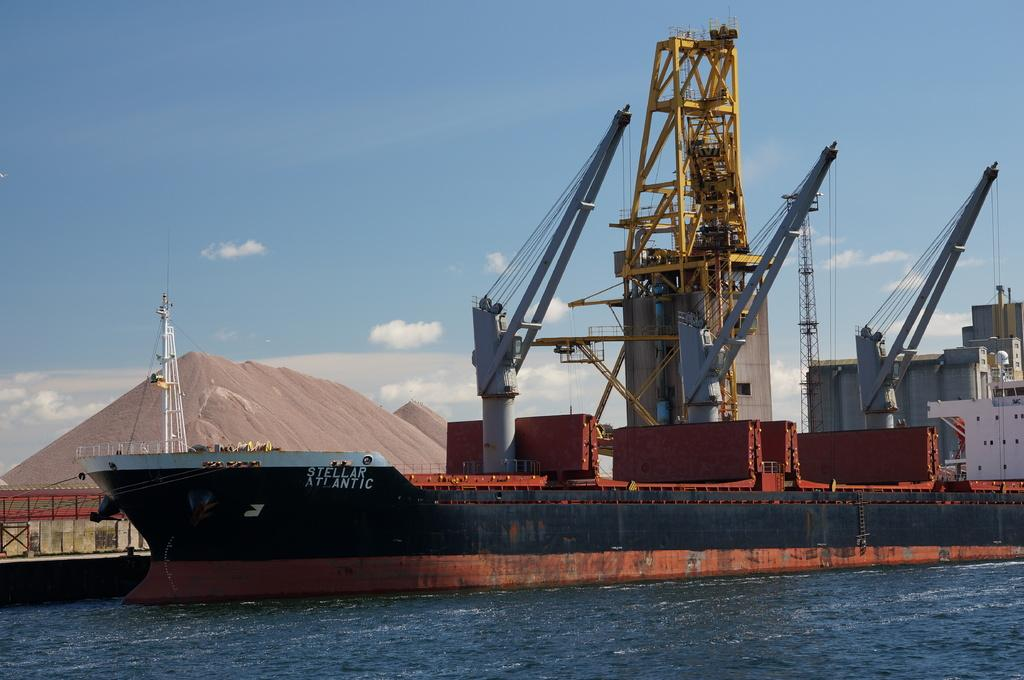What is the main subject of the image? The main subject of the image is a ship in the water. What type of location is depicted in the image? The image shows a harbor. What structures can be seen in the harbor? There are buildings in the harbor. What additional feature can be found in the harbor? There are sand pyramids in the harbor. What type of pencil can be seen in the image? There is no pencil present in the image. What scientific theory is being demonstrated in the image? There is no scientific theory being demonstrated in the image. 